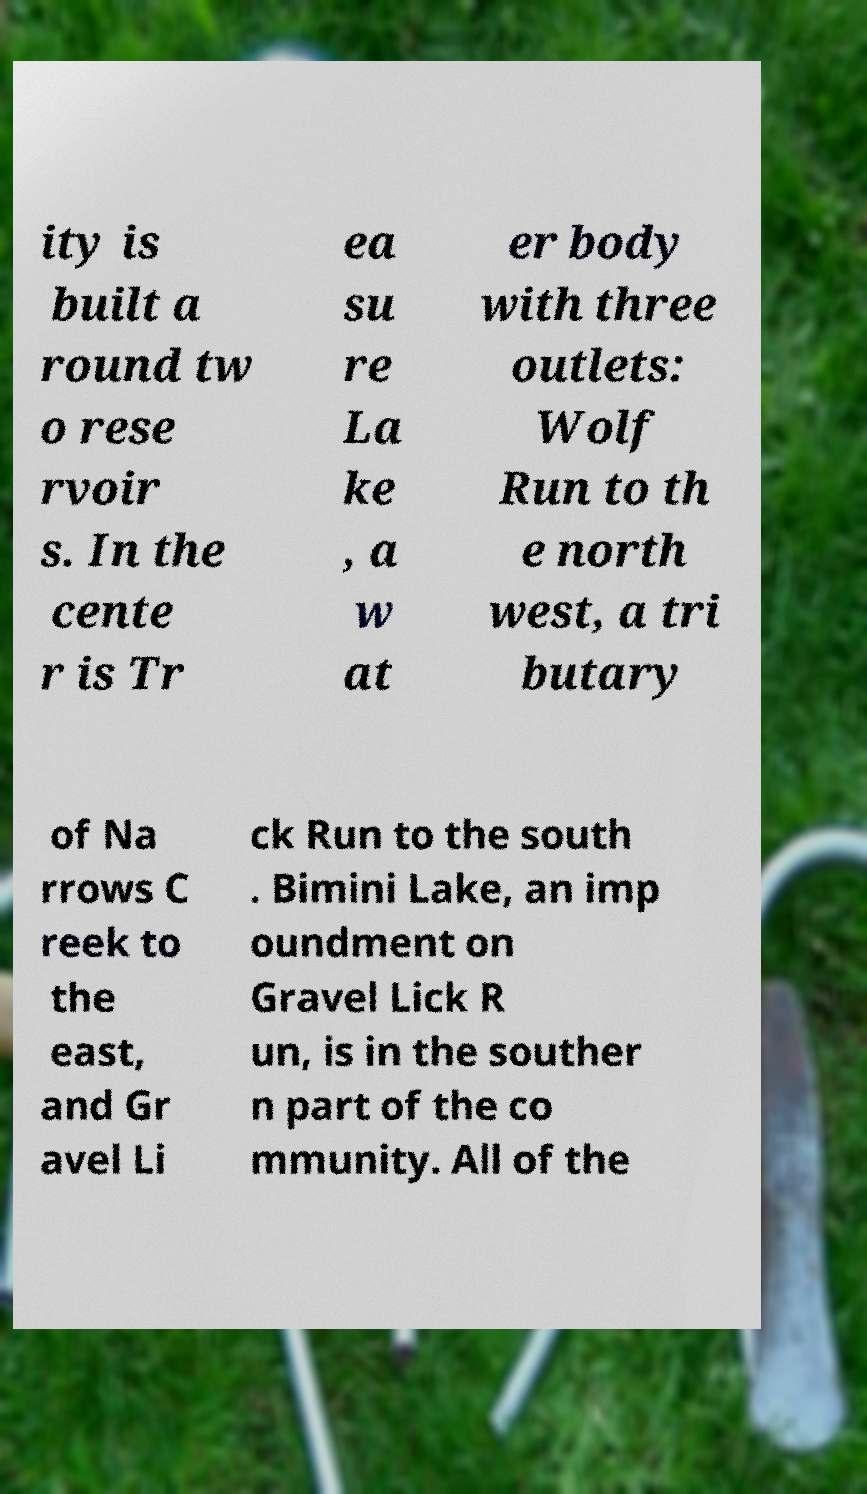What messages or text are displayed in this image? I need them in a readable, typed format. ity is built a round tw o rese rvoir s. In the cente r is Tr ea su re La ke , a w at er body with three outlets: Wolf Run to th e north west, a tri butary of Na rrows C reek to the east, and Gr avel Li ck Run to the south . Bimini Lake, an imp oundment on Gravel Lick R un, is in the souther n part of the co mmunity. All of the 